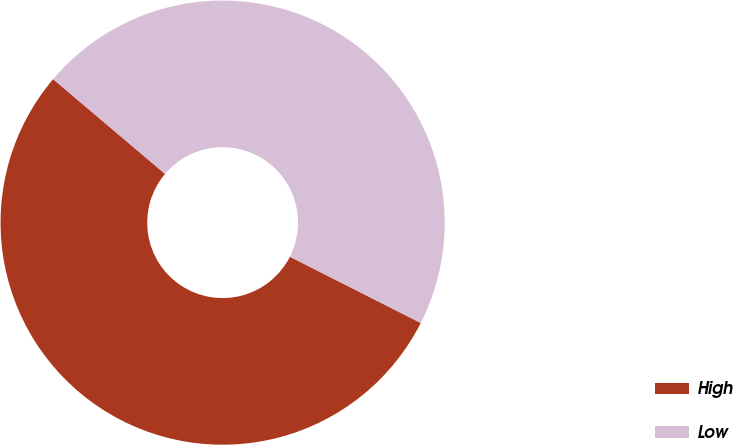<chart> <loc_0><loc_0><loc_500><loc_500><pie_chart><fcel>High<fcel>Low<nl><fcel>53.72%<fcel>46.28%<nl></chart> 